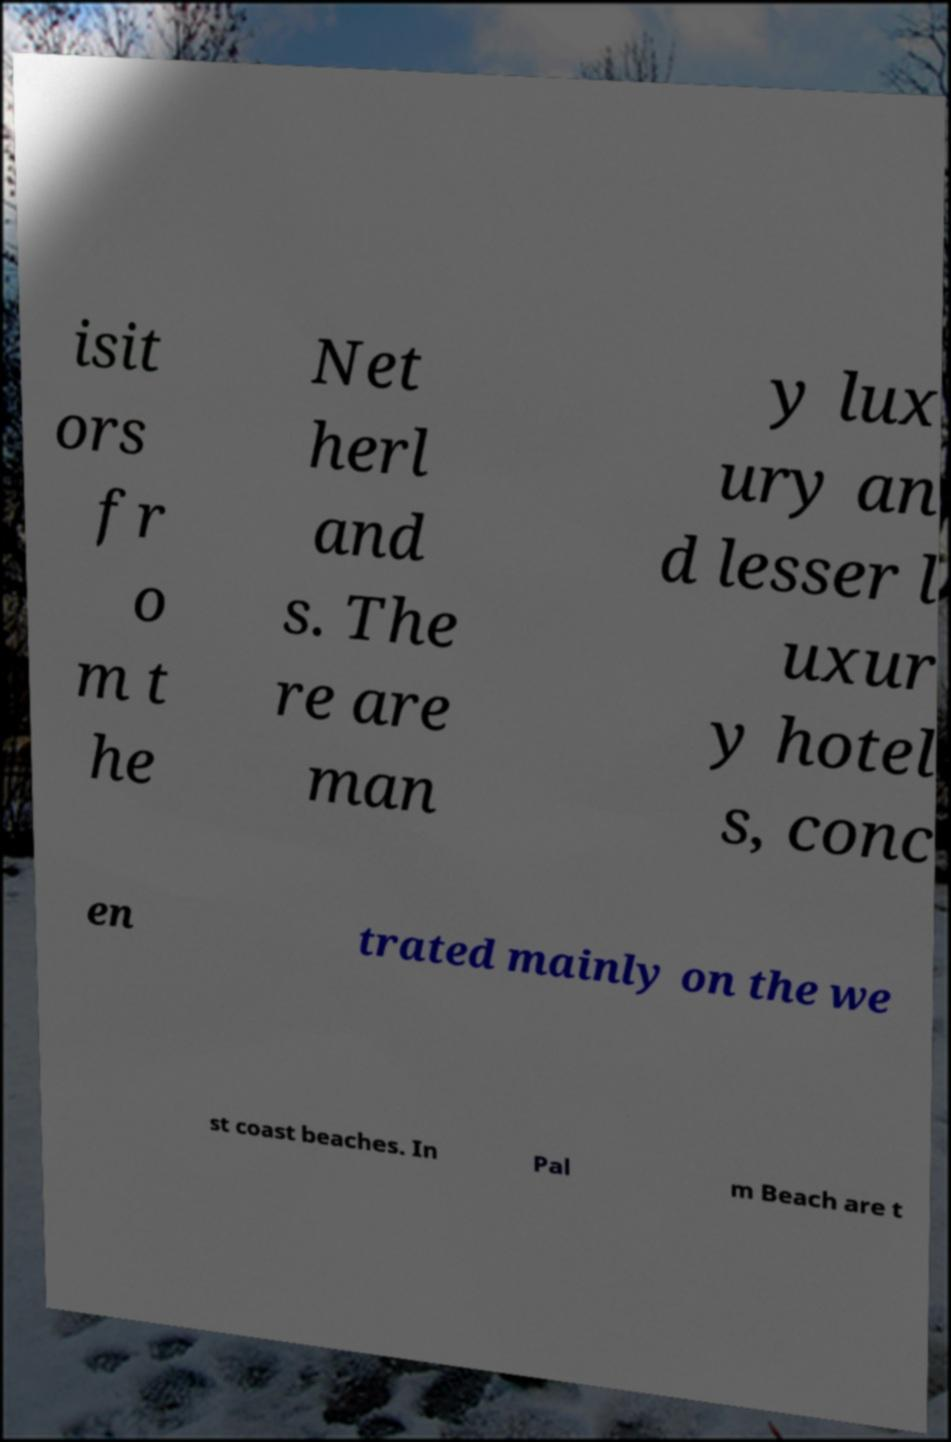Could you assist in decoding the text presented in this image and type it out clearly? isit ors fr o m t he Net herl and s. The re are man y lux ury an d lesser l uxur y hotel s, conc en trated mainly on the we st coast beaches. In Pal m Beach are t 